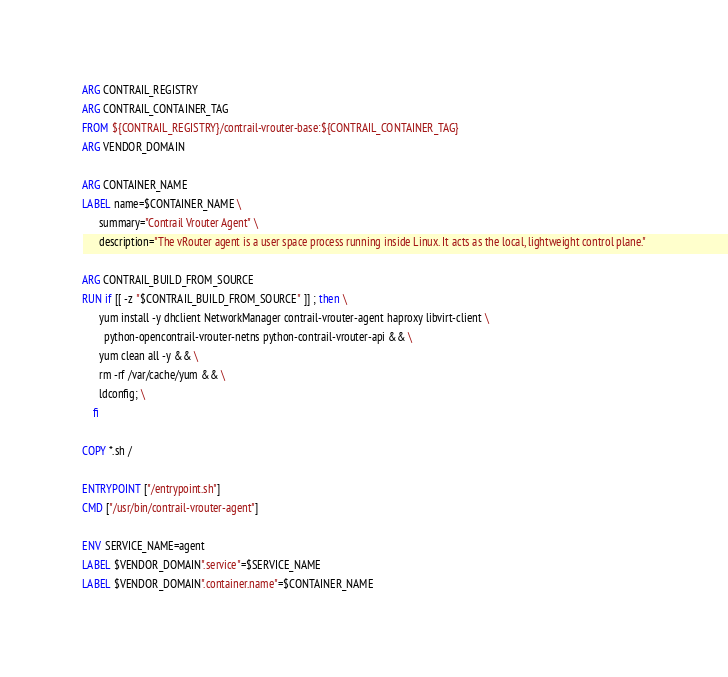Convert code to text. <code><loc_0><loc_0><loc_500><loc_500><_Dockerfile_>ARG CONTRAIL_REGISTRY
ARG CONTRAIL_CONTAINER_TAG
FROM ${CONTRAIL_REGISTRY}/contrail-vrouter-base:${CONTRAIL_CONTAINER_TAG}
ARG VENDOR_DOMAIN

ARG CONTAINER_NAME
LABEL name=$CONTAINER_NAME \
      summary="Contrail Vrouter Agent" \
      description="The vRouter agent is a user space process running inside Linux. It acts as the local, lightweight control plane."

ARG CONTRAIL_BUILD_FROM_SOURCE
RUN if [[ -z "$CONTRAIL_BUILD_FROM_SOURCE" ]] ; then \
      yum install -y dhclient NetworkManager contrail-vrouter-agent haproxy libvirt-client \
        python-opencontrail-vrouter-netns python-contrail-vrouter-api && \
      yum clean all -y && \
      rm -rf /var/cache/yum && \
      ldconfig; \
    fi

COPY *.sh /

ENTRYPOINT ["/entrypoint.sh"]
CMD ["/usr/bin/contrail-vrouter-agent"]

ENV SERVICE_NAME=agent
LABEL $VENDOR_DOMAIN".service"=$SERVICE_NAME
LABEL $VENDOR_DOMAIN".container.name"=$CONTAINER_NAME
</code> 